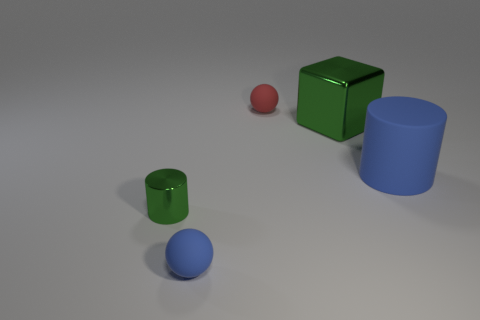Add 2 gray metal balls. How many objects exist? 7 Subtract all small green shiny cylinders. Subtract all blocks. How many objects are left? 3 Add 1 large green metal things. How many large green metal things are left? 2 Add 4 big blue rubber things. How many big blue rubber things exist? 5 Subtract 0 cyan balls. How many objects are left? 5 Subtract all cubes. How many objects are left? 4 